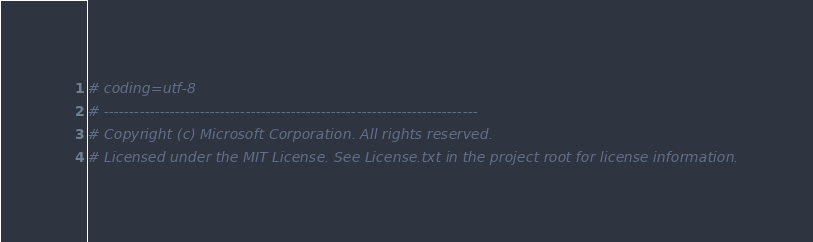Convert code to text. <code><loc_0><loc_0><loc_500><loc_500><_Python_># coding=utf-8
# --------------------------------------------------------------------------
# Copyright (c) Microsoft Corporation. All rights reserved.
# Licensed under the MIT License. See License.txt in the project root for license information.</code> 